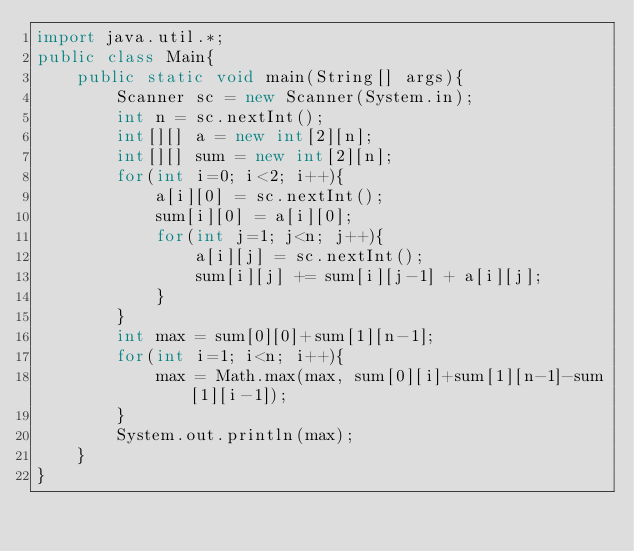<code> <loc_0><loc_0><loc_500><loc_500><_Java_>import java.util.*;
public class Main{
	public static void main(String[] args){
		Scanner sc = new Scanner(System.in);
		int n = sc.nextInt();
		int[][] a = new int[2][n];
		int[][] sum = new int[2][n];
		for(int i=0; i<2; i++){
			a[i][0] = sc.nextInt();
			sum[i][0] = a[i][0];
			for(int j=1; j<n; j++){
				a[i][j] = sc.nextInt();
				sum[i][j] += sum[i][j-1] + a[i][j];
			}
		}
		int max = sum[0][0]+sum[1][n-1];
		for(int i=1; i<n; i++){
			max = Math.max(max, sum[0][i]+sum[1][n-1]-sum[1][i-1]);
		}
		System.out.println(max);
	}
}</code> 